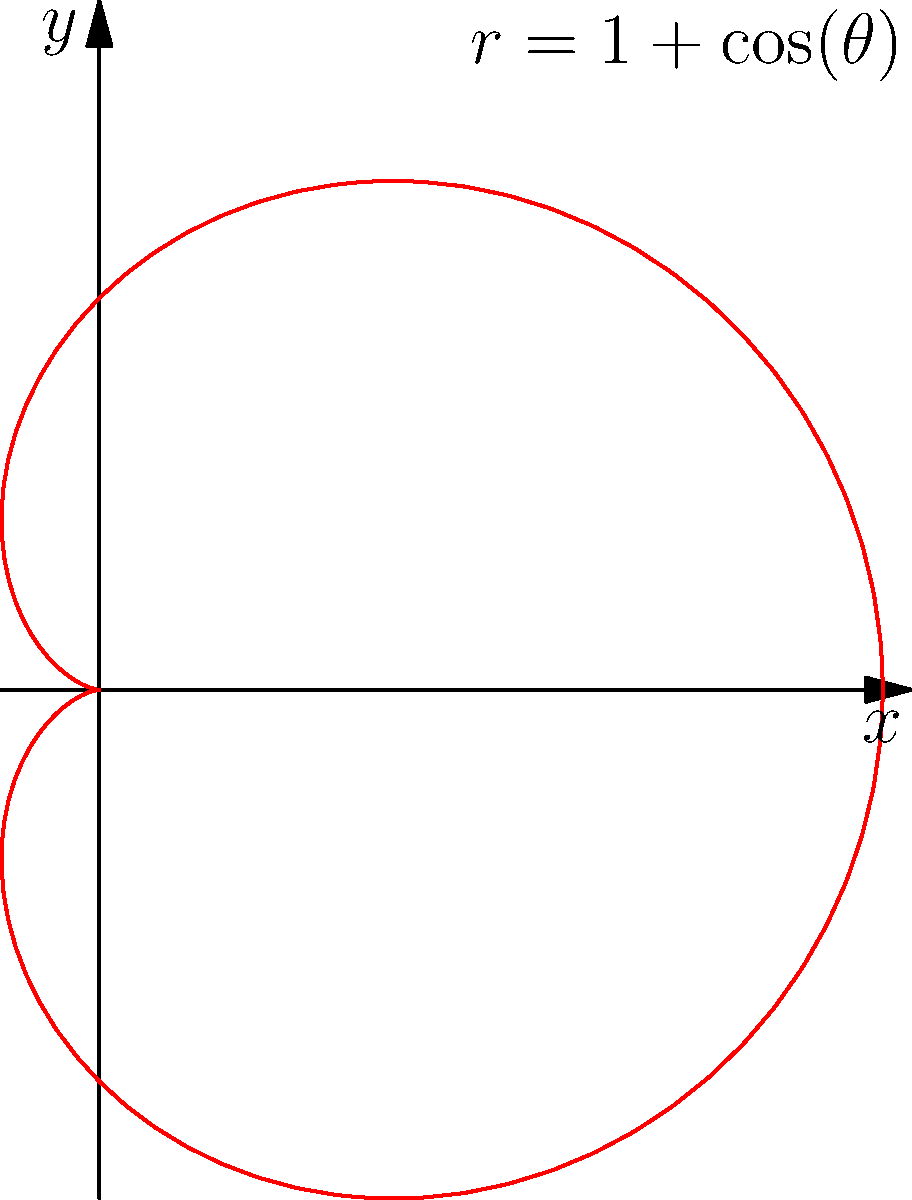Given the polar equation $r = 1 + \cos(\theta)$, which represents a cardioid, what is the maximum distance from the origin to any point on the curve? To find the maximum distance from the origin to any point on the cardioid, we need to follow these steps:

1) The equation of the cardioid is given by $r = 1 + \cos(\theta)$.

2) The maximum value of $r$ will occur when $\cos(\theta)$ is at its maximum.

3) We know that the maximum value of cosine is 1, which occurs when $\theta = 0$ or any multiple of $2\pi$.

4) When $\cos(\theta) = 1$, we have:

   $r_{max} = 1 + 1 = 2$

5) Therefore, the maximum distance from the origin to any point on the cardioid is 2 units.

This can be visually confirmed in the graph, where the curve extends 2 units to the right of the origin along the positive x-axis.
Answer: 2 units 